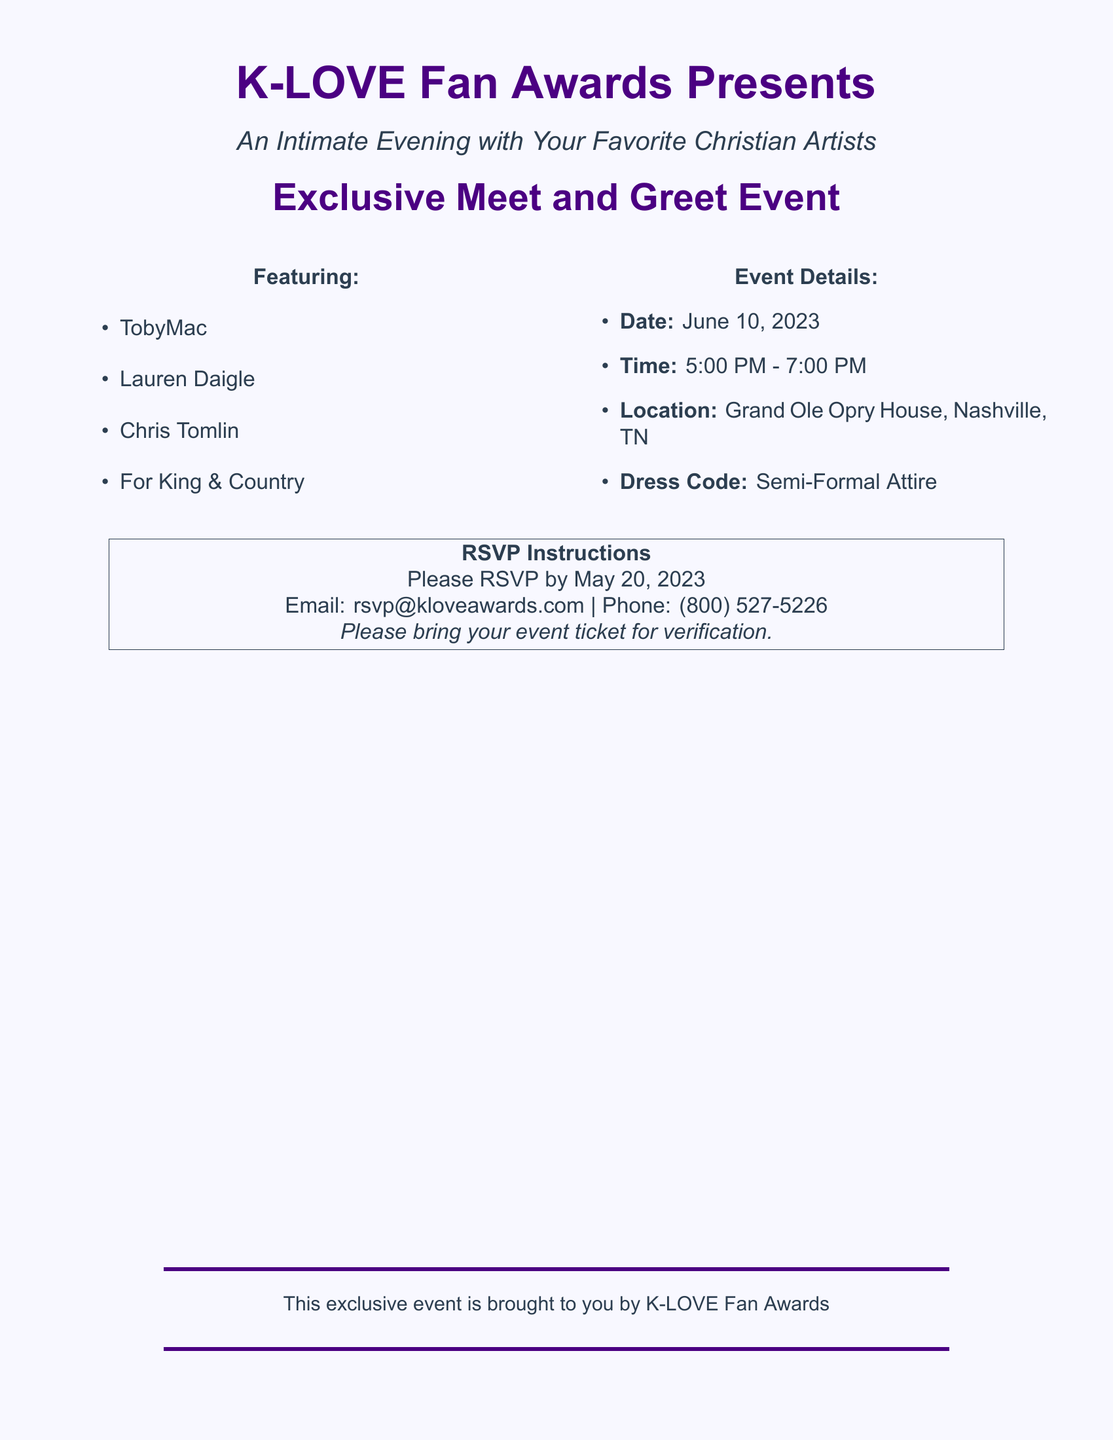What is the name of the event? The name of the event is highlighted in the document as "Exclusive Meet and Greet Event."
Answer: Exclusive Meet and Greet Event Who are some of the featured artists? The document lists the featured artists under the "Featuring" section, including TobyMac, Lauren Daigle, Chris Tomlin, and For King & Country.
Answer: TobyMac, Lauren Daigle, Chris Tomlin, For King & Country What is the RSVP deadline? The RSVP instructions specify the deadline as May 20, 2023.
Answer: May 20, 2023 When is the event taking place? The event date is mentioned clearly as June 10, 2023.
Answer: June 10, 2023 What is the dress code for the event? The dress code is specified in the "Event Details" section.
Answer: Semi-Formal Attire What time does the event start? The starting time for the event is provided in the details as 5:00 PM.
Answer: 5:00 PM Where is the event located? The location of the event is stated in the document as the Grand Ole Opry House, Nashville, TN.
Answer: Grand Ole Opry House, Nashville, TN What do attendees need to bring for verification? The RSVP instructions indicate that attendees should bring their event ticket for verification.
Answer: Event ticket 